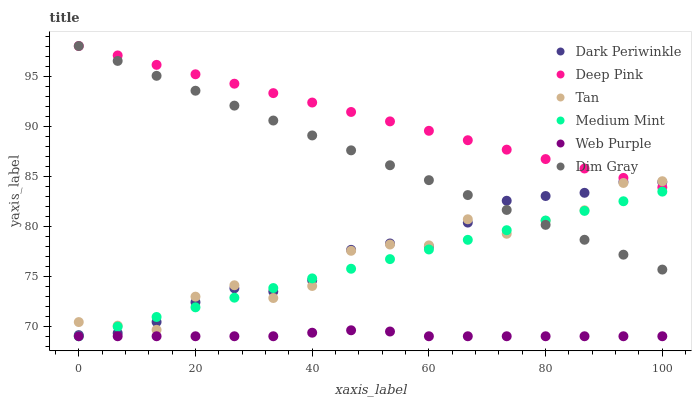Does Web Purple have the minimum area under the curve?
Answer yes or no. Yes. Does Deep Pink have the maximum area under the curve?
Answer yes or no. Yes. Does Deep Pink have the minimum area under the curve?
Answer yes or no. No. Does Web Purple have the maximum area under the curve?
Answer yes or no. No. Is Medium Mint the smoothest?
Answer yes or no. Yes. Is Tan the roughest?
Answer yes or no. Yes. Is Deep Pink the smoothest?
Answer yes or no. No. Is Deep Pink the roughest?
Answer yes or no. No. Does Medium Mint have the lowest value?
Answer yes or no. Yes. Does Deep Pink have the lowest value?
Answer yes or no. No. Does Dim Gray have the highest value?
Answer yes or no. Yes. Does Web Purple have the highest value?
Answer yes or no. No. Is Web Purple less than Tan?
Answer yes or no. Yes. Is Dim Gray greater than Web Purple?
Answer yes or no. Yes. Does Dark Periwinkle intersect Medium Mint?
Answer yes or no. Yes. Is Dark Periwinkle less than Medium Mint?
Answer yes or no. No. Is Dark Periwinkle greater than Medium Mint?
Answer yes or no. No. Does Web Purple intersect Tan?
Answer yes or no. No. 